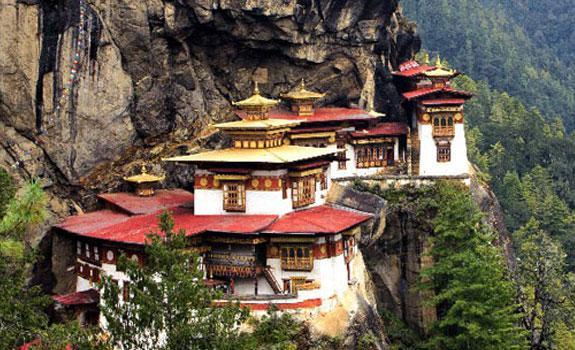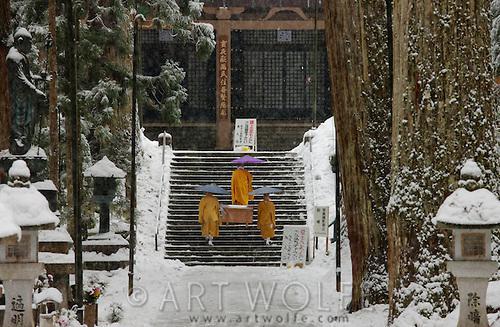The first image is the image on the left, the second image is the image on the right. Given the left and right images, does the statement "One photo shows one or more monks with yellow robes and an umbrella." hold true? Answer yes or no. Yes. The first image is the image on the left, the second image is the image on the right. For the images displayed, is the sentence "There is at least one person dressed in a yellow robe carrying an umbrella" factually correct? Answer yes or no. Yes. 